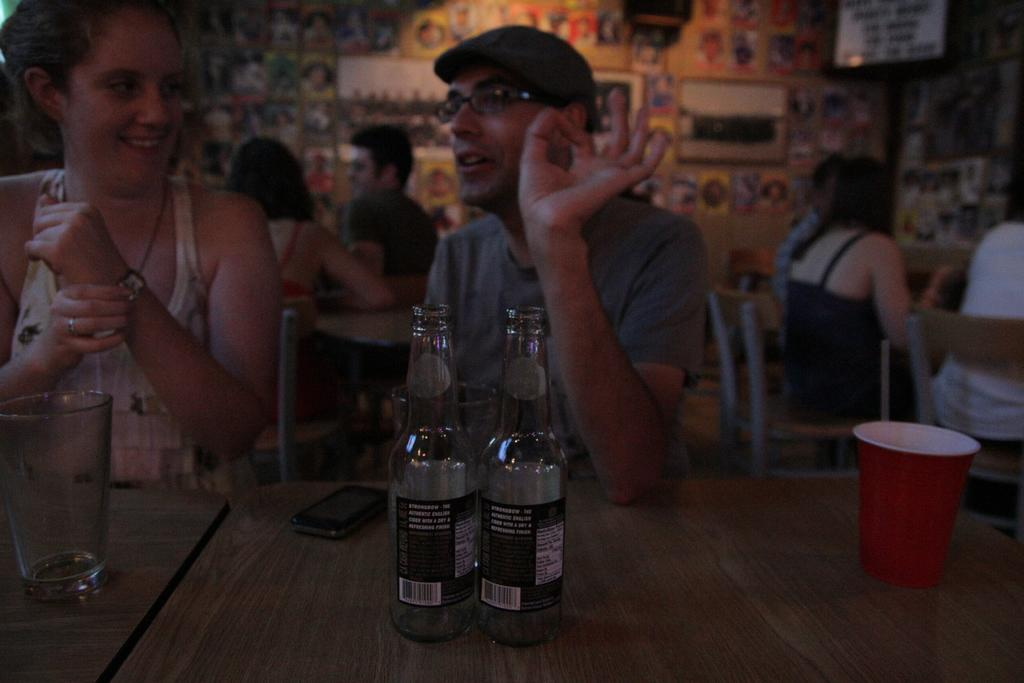What can be seen on the wall in the background of the image? There is a wall with posters in the background. What are the people in the image doing? There are persons sitting on chairs in front of a table. What objects are on the table? There are bottles, a mobile, and glasses on the table. What type of flowers are on the table in the image? There are no flowers present on the table in the image. What is the desire of the person sitting on the left chair? The image does not provide information about the desires of the people in the image. 